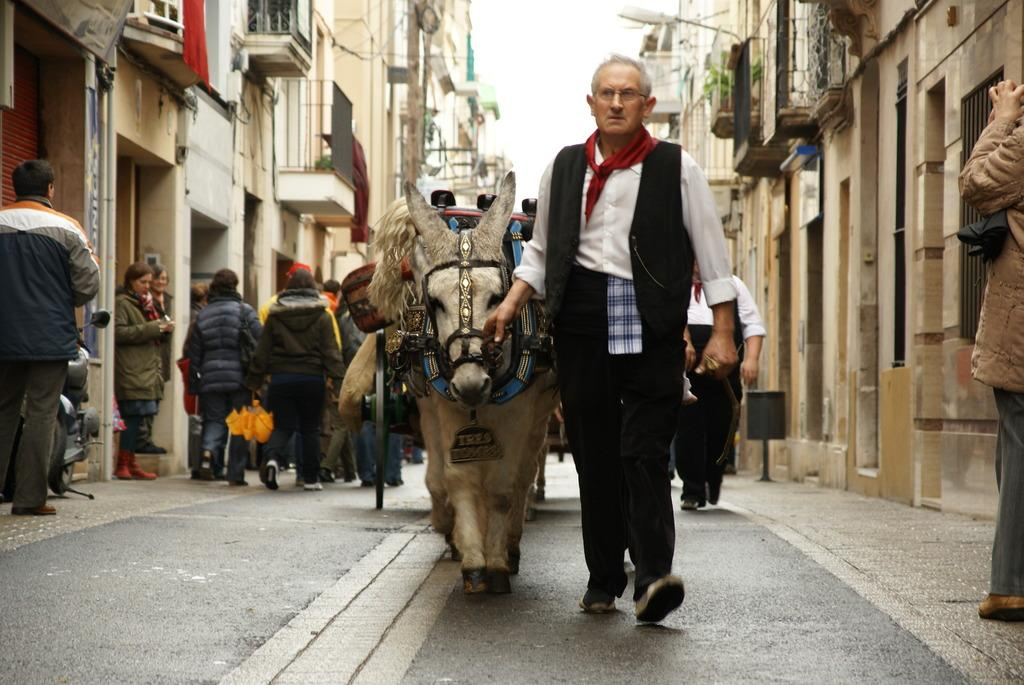What type of structures can be seen in the image? There are buildings in the image. What are some of the activities being performed by people in the image? Some people are walking, and others are standing in the image. Can you describe the man and the donkey in the image? The man is holding a donkey with a string, and he is walking with the donkey. The donkey has a cart attached to it. What type of guitar can be seen in the hands of the man walking with the donkey? There is no guitar present in the image; the man is holding a donkey with a string. Is there a turkey walking alongside the man and the donkey in the image? There is no turkey present in the image; the man is walking with a donkey that has a cart attached to it. 